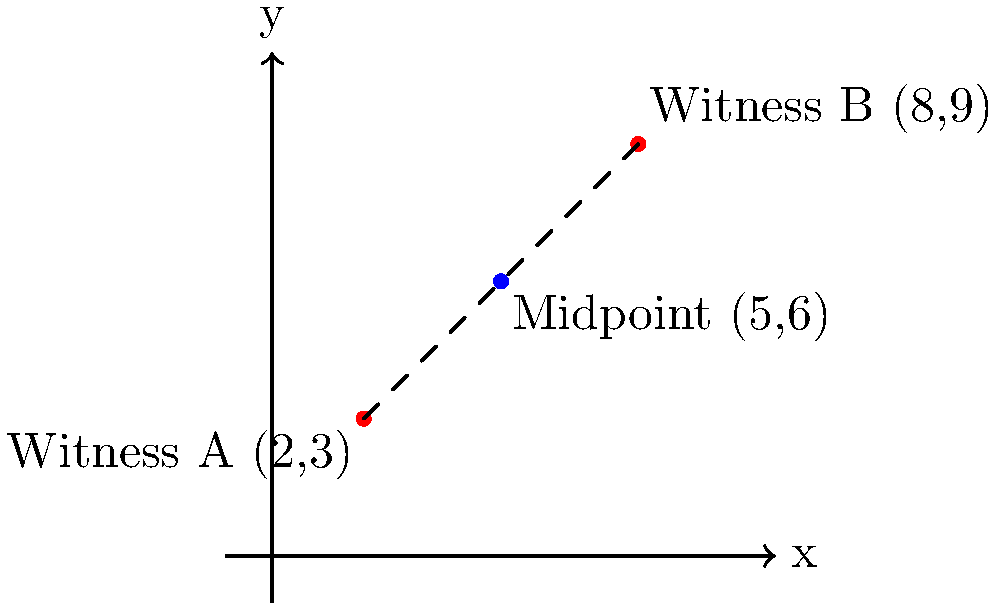Two witnesses to a crime have reported their locations on a coordinate plane. Witness A is at point (2,3), and Witness B is at point (8,9). To determine the best location for setting up a temporary command post, you need to find the midpoint between these two witness locations. What are the coordinates of this midpoint? To find the midpoint between two points, we use the midpoint formula:

$$ \text{Midpoint} = \left(\frac{x_1 + x_2}{2}, \frac{y_1 + y_2}{2}\right) $$

Where $(x_1, y_1)$ are the coordinates of the first point and $(x_2, y_2)$ are the coordinates of the second point.

Step 1: Identify the coordinates
Witness A: $(x_1, y_1) = (2, 3)$
Witness B: $(x_2, y_2) = (8, 9)$

Step 2: Calculate the x-coordinate of the midpoint
$$ x_{\text{midpoint}} = \frac{x_1 + x_2}{2} = \frac{2 + 8}{2} = \frac{10}{2} = 5 $$

Step 3: Calculate the y-coordinate of the midpoint
$$ y_{\text{midpoint}} = \frac{y_1 + y_2}{2} = \frac{3 + 9}{2} = \frac{12}{2} = 6 $$

Step 4: Combine the results
The midpoint coordinates are $(5, 6)$.
Answer: (5, 6) 